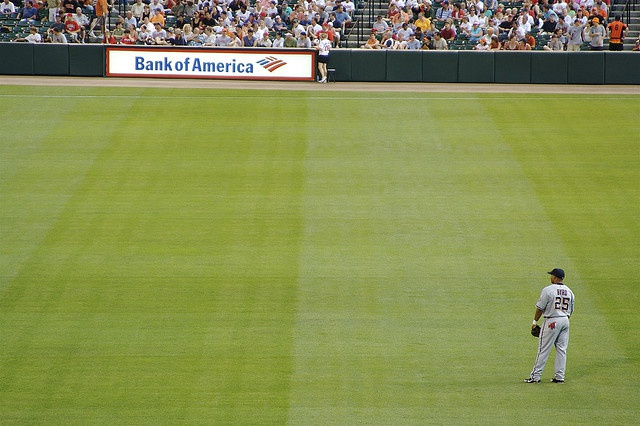Describe the objects in this image and their specific colors. I can see people in black, gray, darkgray, and lightgray tones, people in black, darkgray, gray, and lightgray tones, people in black, lightgray, darkgray, and gray tones, people in black, maroon, brown, and tan tones, and people in black, darkgray, and gray tones in this image. 